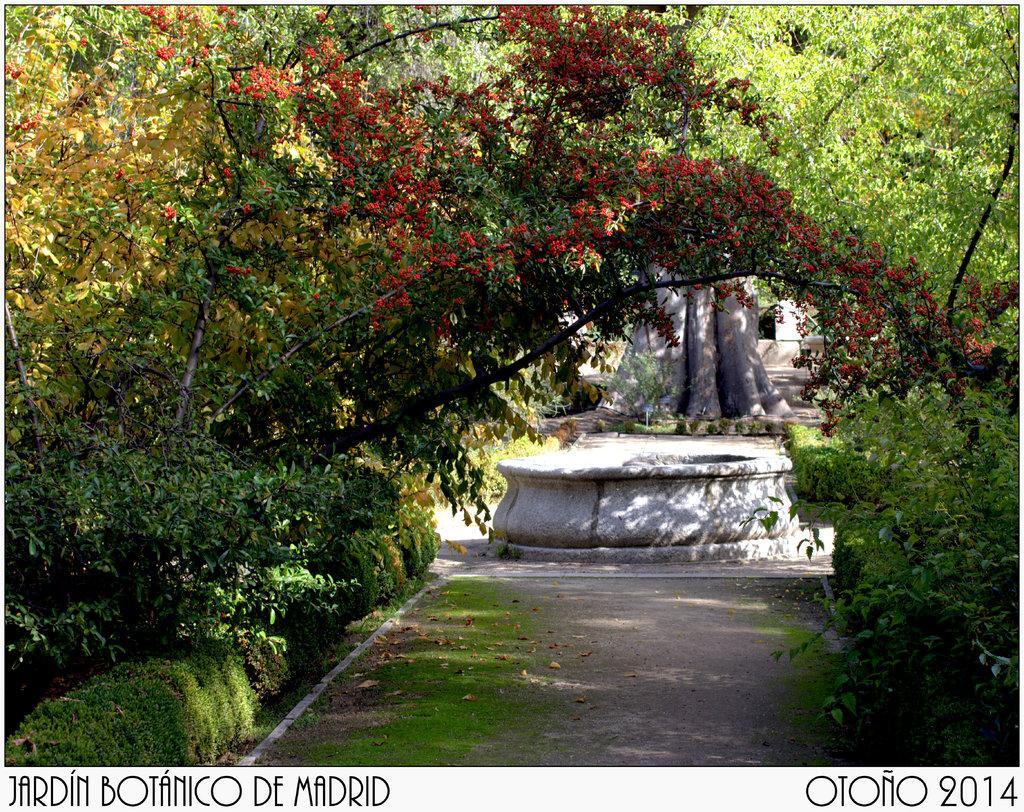Could you give a brief overview of what you see in this image? In this picture I can see plants and trees. I can see words and numbers on the image. 